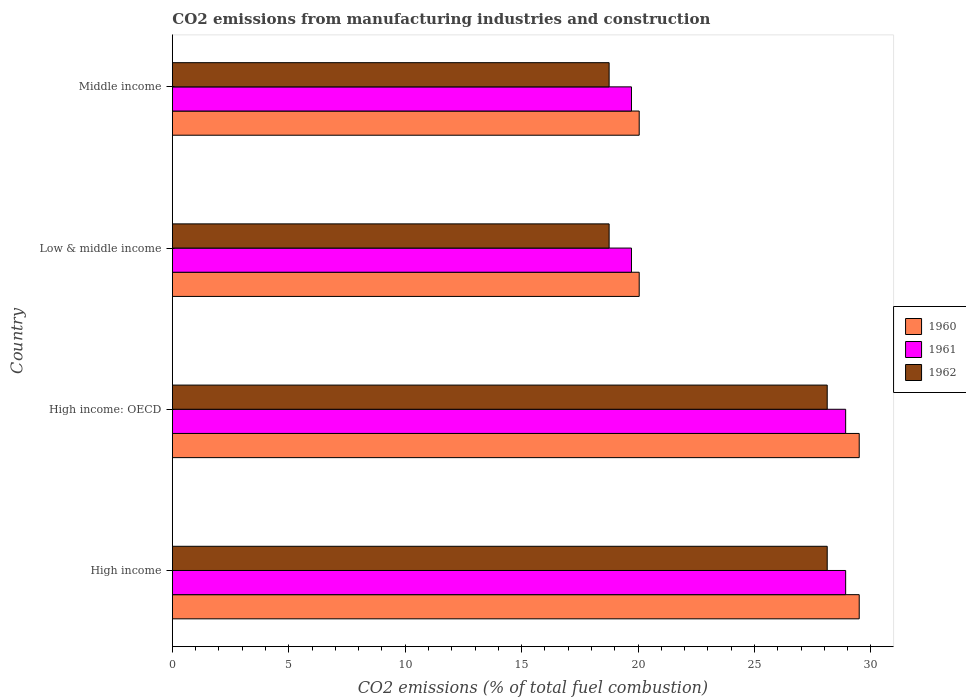How many groups of bars are there?
Make the answer very short. 4. Are the number of bars per tick equal to the number of legend labels?
Keep it short and to the point. Yes. Are the number of bars on each tick of the Y-axis equal?
Provide a succinct answer. Yes. How many bars are there on the 4th tick from the bottom?
Provide a short and direct response. 3. What is the label of the 3rd group of bars from the top?
Your response must be concise. High income: OECD. In how many cases, is the number of bars for a given country not equal to the number of legend labels?
Your answer should be compact. 0. What is the amount of CO2 emitted in 1960 in High income: OECD?
Offer a very short reply. 29.5. Across all countries, what is the maximum amount of CO2 emitted in 1960?
Make the answer very short. 29.5. Across all countries, what is the minimum amount of CO2 emitted in 1960?
Provide a short and direct response. 20.05. In which country was the amount of CO2 emitted in 1961 maximum?
Offer a very short reply. High income. In which country was the amount of CO2 emitted in 1961 minimum?
Make the answer very short. Low & middle income. What is the total amount of CO2 emitted in 1960 in the graph?
Give a very brief answer. 99.09. What is the difference between the amount of CO2 emitted in 1960 in High income and that in Low & middle income?
Offer a terse response. 9.45. What is the difference between the amount of CO2 emitted in 1961 in High income: OECD and the amount of CO2 emitted in 1960 in High income?
Keep it short and to the point. -0.58. What is the average amount of CO2 emitted in 1960 per country?
Keep it short and to the point. 24.77. What is the difference between the amount of CO2 emitted in 1962 and amount of CO2 emitted in 1960 in Low & middle income?
Offer a terse response. -1.29. In how many countries, is the amount of CO2 emitted in 1961 greater than 10 %?
Give a very brief answer. 4. What is the ratio of the amount of CO2 emitted in 1961 in High income: OECD to that in Middle income?
Ensure brevity in your answer.  1.47. Is the difference between the amount of CO2 emitted in 1962 in High income and Low & middle income greater than the difference between the amount of CO2 emitted in 1960 in High income and Low & middle income?
Give a very brief answer. No. What is the difference between the highest and the lowest amount of CO2 emitted in 1962?
Your answer should be compact. 9.37. In how many countries, is the amount of CO2 emitted in 1962 greater than the average amount of CO2 emitted in 1962 taken over all countries?
Make the answer very short. 2. Is the sum of the amount of CO2 emitted in 1960 in High income and High income: OECD greater than the maximum amount of CO2 emitted in 1962 across all countries?
Provide a short and direct response. Yes. What does the 1st bar from the top in Middle income represents?
Give a very brief answer. 1962. What does the 2nd bar from the bottom in High income represents?
Offer a terse response. 1961. Are all the bars in the graph horizontal?
Your answer should be very brief. Yes. What is the difference between two consecutive major ticks on the X-axis?
Ensure brevity in your answer.  5. Does the graph contain any zero values?
Provide a short and direct response. No. Where does the legend appear in the graph?
Offer a very short reply. Center right. What is the title of the graph?
Your answer should be very brief. CO2 emissions from manufacturing industries and construction. Does "1979" appear as one of the legend labels in the graph?
Offer a very short reply. No. What is the label or title of the X-axis?
Keep it short and to the point. CO2 emissions (% of total fuel combustion). What is the label or title of the Y-axis?
Give a very brief answer. Country. What is the CO2 emissions (% of total fuel combustion) of 1960 in High income?
Provide a short and direct response. 29.5. What is the CO2 emissions (% of total fuel combustion) in 1961 in High income?
Give a very brief answer. 28.92. What is the CO2 emissions (% of total fuel combustion) of 1962 in High income?
Provide a short and direct response. 28.12. What is the CO2 emissions (% of total fuel combustion) in 1960 in High income: OECD?
Offer a very short reply. 29.5. What is the CO2 emissions (% of total fuel combustion) of 1961 in High income: OECD?
Keep it short and to the point. 28.92. What is the CO2 emissions (% of total fuel combustion) of 1962 in High income: OECD?
Offer a terse response. 28.12. What is the CO2 emissions (% of total fuel combustion) in 1960 in Low & middle income?
Offer a terse response. 20.05. What is the CO2 emissions (% of total fuel combustion) of 1961 in Low & middle income?
Give a very brief answer. 19.72. What is the CO2 emissions (% of total fuel combustion) of 1962 in Low & middle income?
Your answer should be very brief. 18.76. What is the CO2 emissions (% of total fuel combustion) of 1960 in Middle income?
Keep it short and to the point. 20.05. What is the CO2 emissions (% of total fuel combustion) of 1961 in Middle income?
Offer a terse response. 19.72. What is the CO2 emissions (% of total fuel combustion) in 1962 in Middle income?
Offer a very short reply. 18.76. Across all countries, what is the maximum CO2 emissions (% of total fuel combustion) of 1960?
Give a very brief answer. 29.5. Across all countries, what is the maximum CO2 emissions (% of total fuel combustion) of 1961?
Give a very brief answer. 28.92. Across all countries, what is the maximum CO2 emissions (% of total fuel combustion) of 1962?
Offer a terse response. 28.12. Across all countries, what is the minimum CO2 emissions (% of total fuel combustion) in 1960?
Provide a succinct answer. 20.05. Across all countries, what is the minimum CO2 emissions (% of total fuel combustion) in 1961?
Offer a terse response. 19.72. Across all countries, what is the minimum CO2 emissions (% of total fuel combustion) in 1962?
Keep it short and to the point. 18.76. What is the total CO2 emissions (% of total fuel combustion) of 1960 in the graph?
Make the answer very short. 99.09. What is the total CO2 emissions (% of total fuel combustion) of 1961 in the graph?
Ensure brevity in your answer.  97.26. What is the total CO2 emissions (% of total fuel combustion) in 1962 in the graph?
Keep it short and to the point. 93.76. What is the difference between the CO2 emissions (% of total fuel combustion) of 1961 in High income and that in High income: OECD?
Keep it short and to the point. 0. What is the difference between the CO2 emissions (% of total fuel combustion) of 1962 in High income and that in High income: OECD?
Your answer should be very brief. 0. What is the difference between the CO2 emissions (% of total fuel combustion) of 1960 in High income and that in Low & middle income?
Keep it short and to the point. 9.45. What is the difference between the CO2 emissions (% of total fuel combustion) in 1961 in High income and that in Low & middle income?
Keep it short and to the point. 9.2. What is the difference between the CO2 emissions (% of total fuel combustion) of 1962 in High income and that in Low & middle income?
Provide a short and direct response. 9.37. What is the difference between the CO2 emissions (% of total fuel combustion) of 1960 in High income and that in Middle income?
Your response must be concise. 9.45. What is the difference between the CO2 emissions (% of total fuel combustion) of 1961 in High income and that in Middle income?
Ensure brevity in your answer.  9.2. What is the difference between the CO2 emissions (% of total fuel combustion) of 1962 in High income and that in Middle income?
Your answer should be very brief. 9.37. What is the difference between the CO2 emissions (% of total fuel combustion) of 1960 in High income: OECD and that in Low & middle income?
Keep it short and to the point. 9.45. What is the difference between the CO2 emissions (% of total fuel combustion) in 1961 in High income: OECD and that in Low & middle income?
Provide a short and direct response. 9.2. What is the difference between the CO2 emissions (% of total fuel combustion) in 1962 in High income: OECD and that in Low & middle income?
Ensure brevity in your answer.  9.37. What is the difference between the CO2 emissions (% of total fuel combustion) in 1960 in High income: OECD and that in Middle income?
Provide a short and direct response. 9.45. What is the difference between the CO2 emissions (% of total fuel combustion) in 1961 in High income: OECD and that in Middle income?
Offer a terse response. 9.2. What is the difference between the CO2 emissions (% of total fuel combustion) in 1962 in High income: OECD and that in Middle income?
Your response must be concise. 9.37. What is the difference between the CO2 emissions (% of total fuel combustion) of 1961 in Low & middle income and that in Middle income?
Ensure brevity in your answer.  0. What is the difference between the CO2 emissions (% of total fuel combustion) of 1960 in High income and the CO2 emissions (% of total fuel combustion) of 1961 in High income: OECD?
Your answer should be compact. 0.58. What is the difference between the CO2 emissions (% of total fuel combustion) of 1960 in High income and the CO2 emissions (% of total fuel combustion) of 1962 in High income: OECD?
Provide a succinct answer. 1.37. What is the difference between the CO2 emissions (% of total fuel combustion) of 1961 in High income and the CO2 emissions (% of total fuel combustion) of 1962 in High income: OECD?
Provide a short and direct response. 0.79. What is the difference between the CO2 emissions (% of total fuel combustion) of 1960 in High income and the CO2 emissions (% of total fuel combustion) of 1961 in Low & middle income?
Make the answer very short. 9.78. What is the difference between the CO2 emissions (% of total fuel combustion) in 1960 in High income and the CO2 emissions (% of total fuel combustion) in 1962 in Low & middle income?
Your response must be concise. 10.74. What is the difference between the CO2 emissions (% of total fuel combustion) of 1961 in High income and the CO2 emissions (% of total fuel combustion) of 1962 in Low & middle income?
Make the answer very short. 10.16. What is the difference between the CO2 emissions (% of total fuel combustion) in 1960 in High income and the CO2 emissions (% of total fuel combustion) in 1961 in Middle income?
Give a very brief answer. 9.78. What is the difference between the CO2 emissions (% of total fuel combustion) in 1960 in High income and the CO2 emissions (% of total fuel combustion) in 1962 in Middle income?
Keep it short and to the point. 10.74. What is the difference between the CO2 emissions (% of total fuel combustion) in 1961 in High income and the CO2 emissions (% of total fuel combustion) in 1962 in Middle income?
Provide a succinct answer. 10.16. What is the difference between the CO2 emissions (% of total fuel combustion) in 1960 in High income: OECD and the CO2 emissions (% of total fuel combustion) in 1961 in Low & middle income?
Make the answer very short. 9.78. What is the difference between the CO2 emissions (% of total fuel combustion) of 1960 in High income: OECD and the CO2 emissions (% of total fuel combustion) of 1962 in Low & middle income?
Give a very brief answer. 10.74. What is the difference between the CO2 emissions (% of total fuel combustion) of 1961 in High income: OECD and the CO2 emissions (% of total fuel combustion) of 1962 in Low & middle income?
Your response must be concise. 10.16. What is the difference between the CO2 emissions (% of total fuel combustion) of 1960 in High income: OECD and the CO2 emissions (% of total fuel combustion) of 1961 in Middle income?
Your answer should be very brief. 9.78. What is the difference between the CO2 emissions (% of total fuel combustion) in 1960 in High income: OECD and the CO2 emissions (% of total fuel combustion) in 1962 in Middle income?
Offer a terse response. 10.74. What is the difference between the CO2 emissions (% of total fuel combustion) of 1961 in High income: OECD and the CO2 emissions (% of total fuel combustion) of 1962 in Middle income?
Provide a succinct answer. 10.16. What is the difference between the CO2 emissions (% of total fuel combustion) of 1960 in Low & middle income and the CO2 emissions (% of total fuel combustion) of 1961 in Middle income?
Give a very brief answer. 0.33. What is the difference between the CO2 emissions (% of total fuel combustion) in 1960 in Low & middle income and the CO2 emissions (% of total fuel combustion) in 1962 in Middle income?
Offer a very short reply. 1.29. What is the difference between the CO2 emissions (% of total fuel combustion) of 1961 in Low & middle income and the CO2 emissions (% of total fuel combustion) of 1962 in Middle income?
Give a very brief answer. 0.96. What is the average CO2 emissions (% of total fuel combustion) of 1960 per country?
Provide a short and direct response. 24.77. What is the average CO2 emissions (% of total fuel combustion) in 1961 per country?
Your response must be concise. 24.32. What is the average CO2 emissions (% of total fuel combustion) of 1962 per country?
Offer a terse response. 23.44. What is the difference between the CO2 emissions (% of total fuel combustion) of 1960 and CO2 emissions (% of total fuel combustion) of 1961 in High income?
Make the answer very short. 0.58. What is the difference between the CO2 emissions (% of total fuel combustion) of 1960 and CO2 emissions (% of total fuel combustion) of 1962 in High income?
Keep it short and to the point. 1.37. What is the difference between the CO2 emissions (% of total fuel combustion) of 1961 and CO2 emissions (% of total fuel combustion) of 1962 in High income?
Give a very brief answer. 0.79. What is the difference between the CO2 emissions (% of total fuel combustion) in 1960 and CO2 emissions (% of total fuel combustion) in 1961 in High income: OECD?
Provide a short and direct response. 0.58. What is the difference between the CO2 emissions (% of total fuel combustion) in 1960 and CO2 emissions (% of total fuel combustion) in 1962 in High income: OECD?
Your answer should be compact. 1.37. What is the difference between the CO2 emissions (% of total fuel combustion) of 1961 and CO2 emissions (% of total fuel combustion) of 1962 in High income: OECD?
Provide a succinct answer. 0.79. What is the difference between the CO2 emissions (% of total fuel combustion) in 1960 and CO2 emissions (% of total fuel combustion) in 1961 in Low & middle income?
Provide a succinct answer. 0.33. What is the difference between the CO2 emissions (% of total fuel combustion) of 1960 and CO2 emissions (% of total fuel combustion) of 1962 in Low & middle income?
Make the answer very short. 1.29. What is the difference between the CO2 emissions (% of total fuel combustion) of 1961 and CO2 emissions (% of total fuel combustion) of 1962 in Low & middle income?
Keep it short and to the point. 0.96. What is the difference between the CO2 emissions (% of total fuel combustion) in 1960 and CO2 emissions (% of total fuel combustion) in 1961 in Middle income?
Give a very brief answer. 0.33. What is the difference between the CO2 emissions (% of total fuel combustion) of 1960 and CO2 emissions (% of total fuel combustion) of 1962 in Middle income?
Ensure brevity in your answer.  1.29. What is the difference between the CO2 emissions (% of total fuel combustion) in 1961 and CO2 emissions (% of total fuel combustion) in 1962 in Middle income?
Offer a very short reply. 0.96. What is the ratio of the CO2 emissions (% of total fuel combustion) of 1960 in High income to that in High income: OECD?
Your answer should be compact. 1. What is the ratio of the CO2 emissions (% of total fuel combustion) of 1960 in High income to that in Low & middle income?
Ensure brevity in your answer.  1.47. What is the ratio of the CO2 emissions (% of total fuel combustion) in 1961 in High income to that in Low & middle income?
Make the answer very short. 1.47. What is the ratio of the CO2 emissions (% of total fuel combustion) of 1962 in High income to that in Low & middle income?
Ensure brevity in your answer.  1.5. What is the ratio of the CO2 emissions (% of total fuel combustion) in 1960 in High income to that in Middle income?
Provide a succinct answer. 1.47. What is the ratio of the CO2 emissions (% of total fuel combustion) in 1961 in High income to that in Middle income?
Offer a very short reply. 1.47. What is the ratio of the CO2 emissions (% of total fuel combustion) in 1962 in High income to that in Middle income?
Your response must be concise. 1.5. What is the ratio of the CO2 emissions (% of total fuel combustion) of 1960 in High income: OECD to that in Low & middle income?
Ensure brevity in your answer.  1.47. What is the ratio of the CO2 emissions (% of total fuel combustion) of 1961 in High income: OECD to that in Low & middle income?
Ensure brevity in your answer.  1.47. What is the ratio of the CO2 emissions (% of total fuel combustion) in 1962 in High income: OECD to that in Low & middle income?
Your answer should be very brief. 1.5. What is the ratio of the CO2 emissions (% of total fuel combustion) of 1960 in High income: OECD to that in Middle income?
Offer a terse response. 1.47. What is the ratio of the CO2 emissions (% of total fuel combustion) in 1961 in High income: OECD to that in Middle income?
Make the answer very short. 1.47. What is the ratio of the CO2 emissions (% of total fuel combustion) of 1962 in High income: OECD to that in Middle income?
Ensure brevity in your answer.  1.5. What is the ratio of the CO2 emissions (% of total fuel combustion) of 1960 in Low & middle income to that in Middle income?
Provide a succinct answer. 1. What is the ratio of the CO2 emissions (% of total fuel combustion) in 1961 in Low & middle income to that in Middle income?
Your answer should be very brief. 1. What is the difference between the highest and the second highest CO2 emissions (% of total fuel combustion) of 1962?
Offer a terse response. 0. What is the difference between the highest and the lowest CO2 emissions (% of total fuel combustion) in 1960?
Ensure brevity in your answer.  9.45. What is the difference between the highest and the lowest CO2 emissions (% of total fuel combustion) of 1961?
Keep it short and to the point. 9.2. What is the difference between the highest and the lowest CO2 emissions (% of total fuel combustion) in 1962?
Provide a succinct answer. 9.37. 